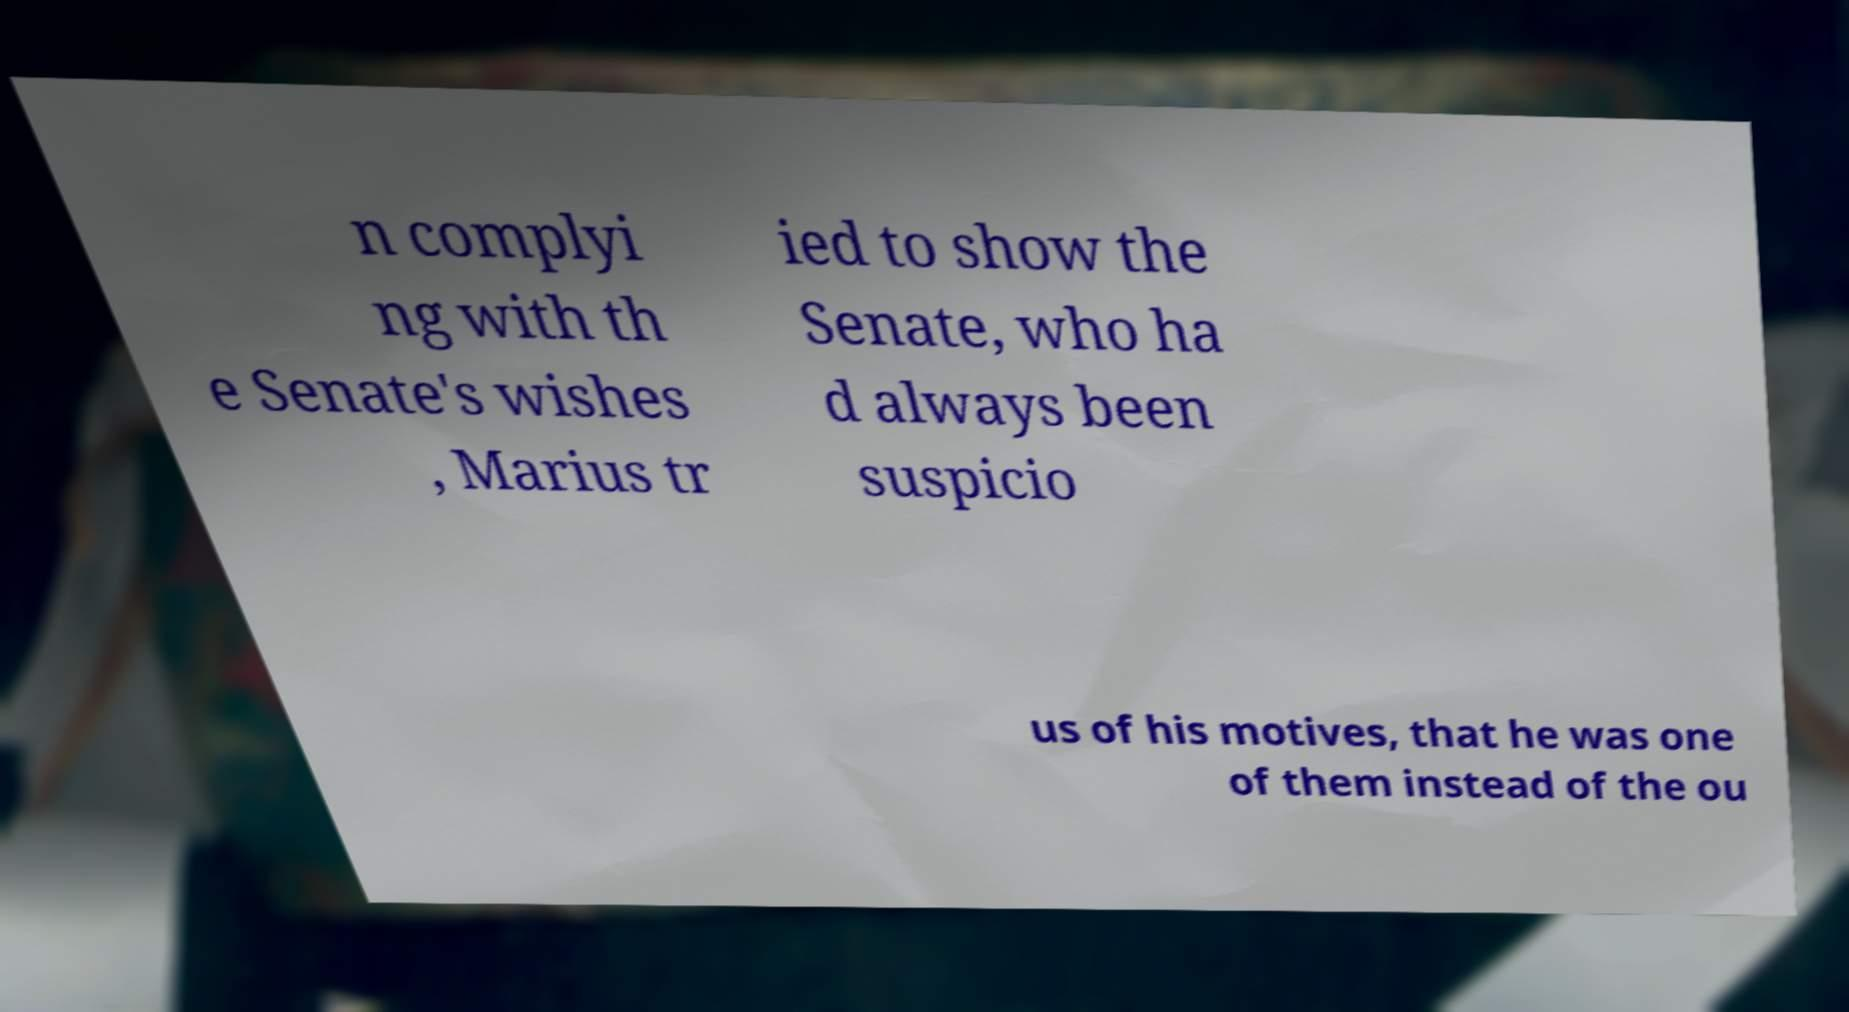What messages or text are displayed in this image? I need them in a readable, typed format. n complyi ng with th e Senate's wishes , Marius tr ied to show the Senate, who ha d always been suspicio us of his motives, that he was one of them instead of the ou 